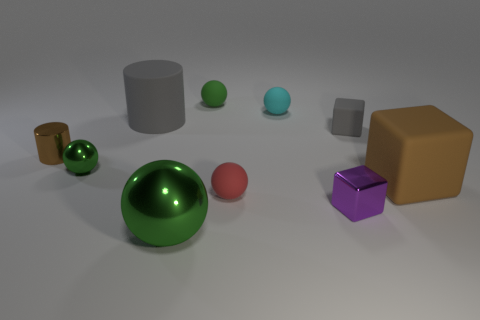What material is the other small ball that is the same color as the small shiny sphere?
Your answer should be very brief. Rubber. What is the size of the gray rubber cube?
Keep it short and to the point. Small. There is a big object that is behind the large rubber object in front of the small green ball that is in front of the small cylinder; what is its material?
Provide a succinct answer. Rubber. How many other objects are the same color as the large metal ball?
Your answer should be very brief. 2. What number of gray objects are either small cylinders or tiny cubes?
Provide a short and direct response. 1. There is a tiny green sphere right of the large cylinder; what material is it?
Your response must be concise. Rubber. Does the thing that is on the right side of the gray cube have the same material as the tiny cyan ball?
Provide a succinct answer. Yes. The small red thing is what shape?
Offer a very short reply. Sphere. There is a gray object that is on the right side of the green metallic object in front of the brown matte cube; how many small green balls are behind it?
Ensure brevity in your answer.  1. What number of other things are there of the same material as the tiny cyan object
Make the answer very short. 5. 